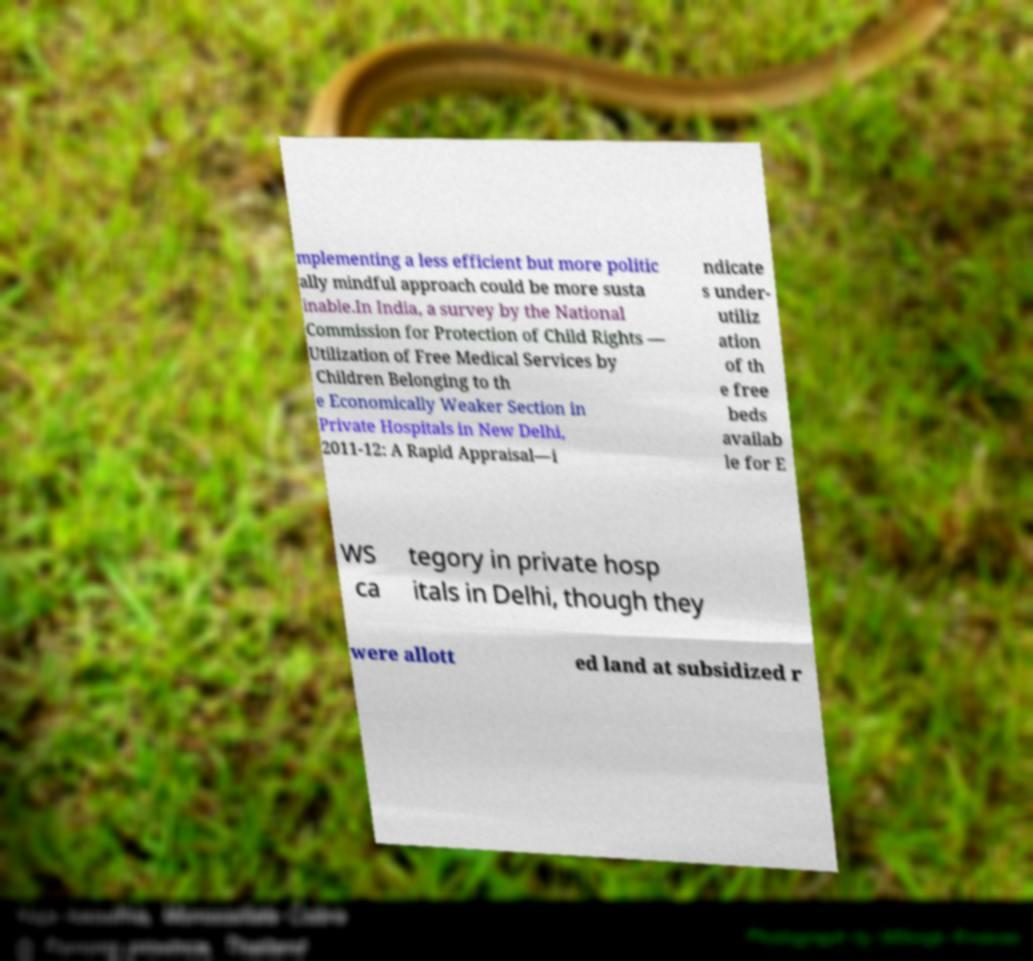Could you extract and type out the text from this image? mplementing a less efficient but more politic ally mindful approach could be more susta inable.In India, a survey by the National Commission for Protection of Child Rights — Utilization of Free Medical Services by Children Belonging to th e Economically Weaker Section in Private Hospitals in New Delhi, 2011-12: A Rapid Appraisal—i ndicate s under- utiliz ation of th e free beds availab le for E WS ca tegory in private hosp itals in Delhi, though they were allott ed land at subsidized r 